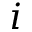Convert formula to latex. <formula><loc_0><loc_0><loc_500><loc_500>i</formula> 